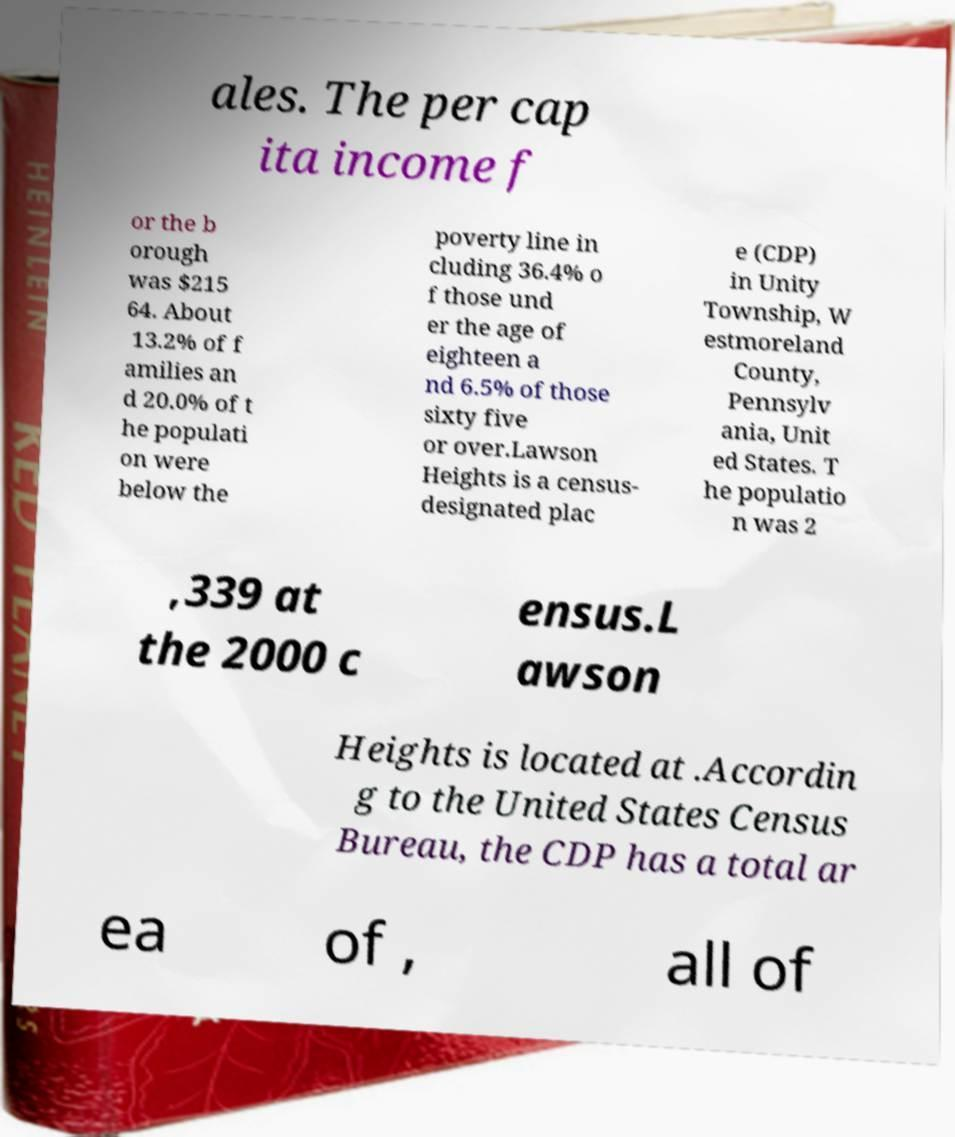Could you extract and type out the text from this image? ales. The per cap ita income f or the b orough was $215 64. About 13.2% of f amilies an d 20.0% of t he populati on were below the poverty line in cluding 36.4% o f those und er the age of eighteen a nd 6.5% of those sixty five or over.Lawson Heights is a census- designated plac e (CDP) in Unity Township, W estmoreland County, Pennsylv ania, Unit ed States. T he populatio n was 2 ,339 at the 2000 c ensus.L awson Heights is located at .Accordin g to the United States Census Bureau, the CDP has a total ar ea of , all of 